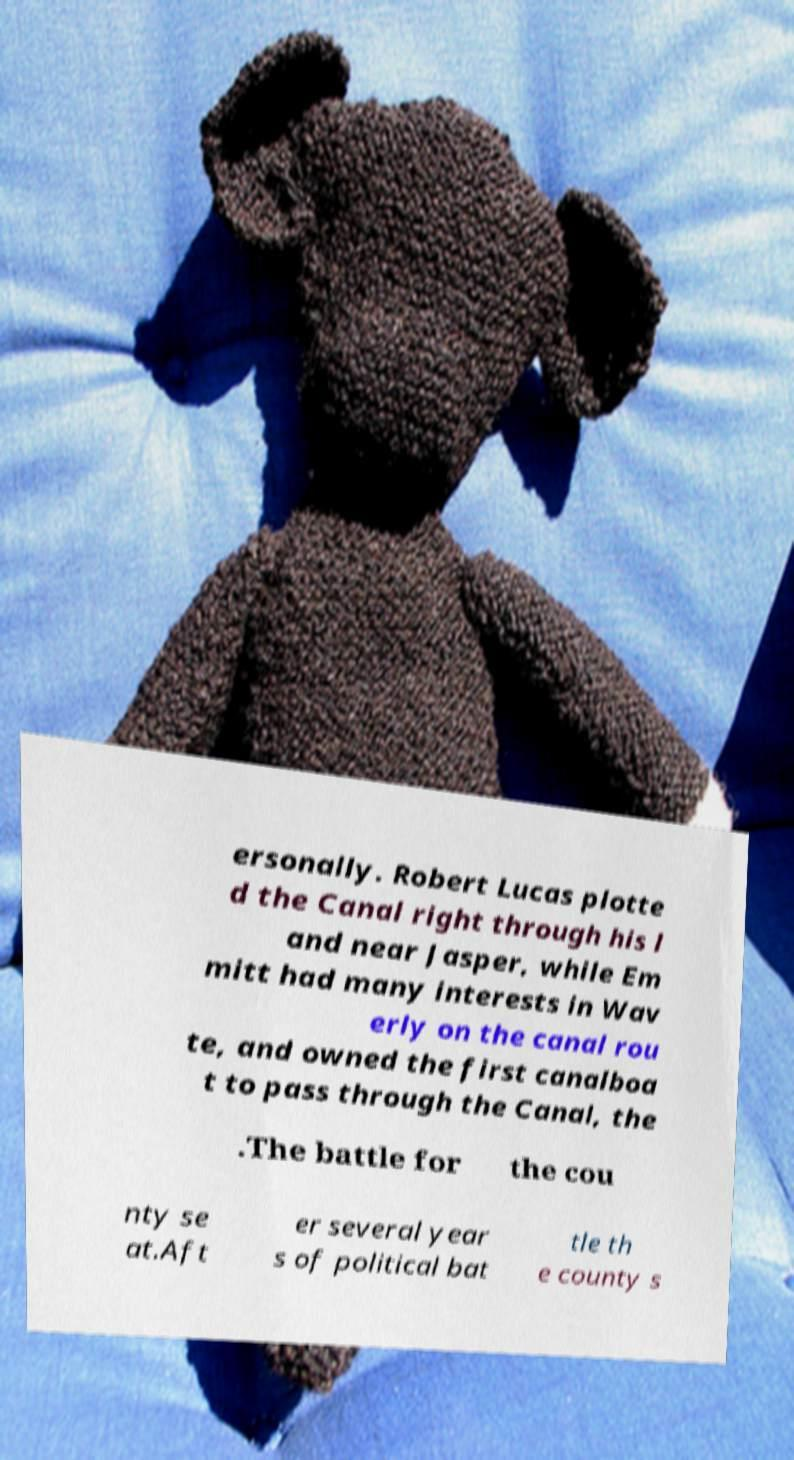Please identify and transcribe the text found in this image. ersonally. Robert Lucas plotte d the Canal right through his l and near Jasper, while Em mitt had many interests in Wav erly on the canal rou te, and owned the first canalboa t to pass through the Canal, the .The battle for the cou nty se at.Aft er several year s of political bat tle th e county s 